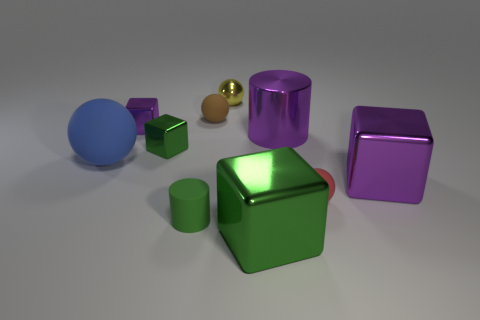Is the number of tiny spheres greater than the number of green cylinders?
Offer a very short reply. Yes. What number of other things are there of the same color as the tiny cylinder?
Make the answer very short. 2. How many things are either small purple metal balls or brown matte spheres?
Ensure brevity in your answer.  1. Is the shape of the purple thing behind the large metallic cylinder the same as  the big matte object?
Give a very brief answer. No. The large shiny thing behind the large cube that is behind the green cylinder is what color?
Your response must be concise. Purple. Are there fewer large purple blocks than balls?
Provide a short and direct response. Yes. Are there any small purple cubes that have the same material as the small yellow object?
Offer a terse response. Yes. Does the small purple metallic object have the same shape as the tiny matte thing that is behind the blue rubber ball?
Make the answer very short. No. There is a small brown rubber object; are there any small brown balls behind it?
Your answer should be very brief. No. What number of other purple shiny things are the same shape as the small purple metallic thing?
Provide a short and direct response. 1. 